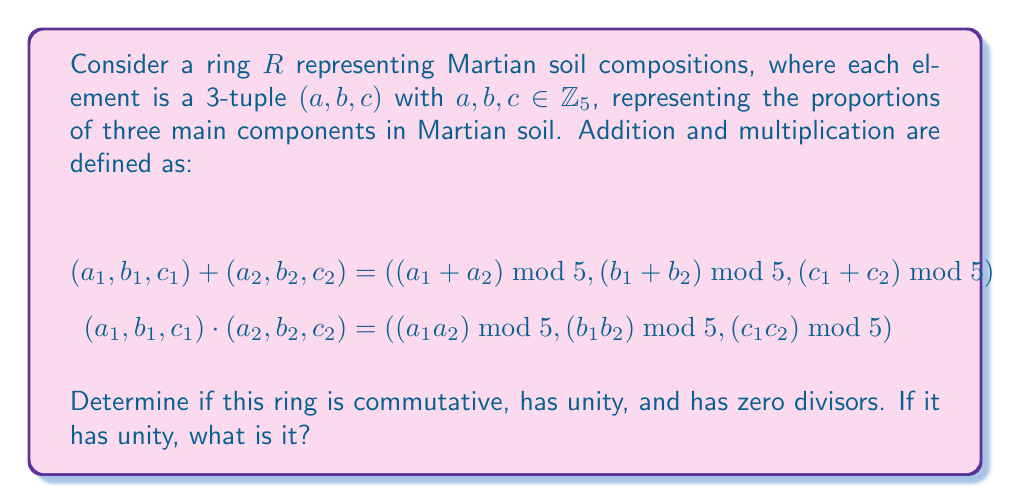Solve this math problem. Let's examine the properties of this ring step by step:

1. Commutativity:
   For addition: $(a_1, b_1, c_1) + (a_2, b_2, c_2) = ((a_1 + a_2) \bmod 5, (b_1 + b_2) \bmod 5, (c_1 + c_2) \bmod 5)$
                $= ((a_2 + a_1) \bmod 5, (b_2 + b_1) \bmod 5, (c_2 + c_1) \bmod 5) = (a_2, b_2, c_2) + (a_1, b_1, c_1)$
   
   For multiplication: $(a_1, b_1, c_1) \cdot (a_2, b_2, c_2) = ((a_1a_2) \bmod 5, (b_1b_2) \bmod 5, (c_1c_2) \bmod 5)$
                      $= ((a_2a_1) \bmod 5, (b_2b_1) \bmod 5, (c_2c_1) \bmod 5) = (a_2, b_2, c_2) \cdot (a_1, b_1, c_1)$

   Therefore, the ring is commutative for both addition and multiplication.

2. Unity:
   The unity element, if it exists, should satisfy $(a, b, c) \cdot (e_1, e_2, e_3) = (a, b, c)$ for all $(a, b, c) \in R$.
   This means: $((ae_1) \bmod 5, (be_2) \bmod 5, (ce_3) \bmod 5) = (a, b, c)$
   The only element satisfying this condition is $(1, 1, 1)$, as:
   $(a, b, c) \cdot (1, 1, 1) = ((a \cdot 1) \bmod 5, (b \cdot 1) \bmod 5, (c \cdot 1) \bmod 5) = (a, b, c)$

   Therefore, the ring has unity, and it is $(1, 1, 1)$.

3. Zero Divisors:
   A zero divisor is a non-zero element $x$ such that there exists a non-zero element $y$ with $xy = 0$.
   In this ring, $(0, 0, 0)$ is the zero element.
   Consider $(0, 1, 0) \cdot (1, 0, 1) = (0, 0, 0)$
   Both $(0, 1, 0)$ and $(1, 0, 1)$ are non-zero elements, but their product is zero.

   Therefore, the ring has zero divisors.
Answer: The ring is commutative, has unity $(1, 1, 1)$, and contains zero divisors. 